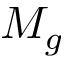Convert formula to latex. <formula><loc_0><loc_0><loc_500><loc_500>M _ { g }</formula> 